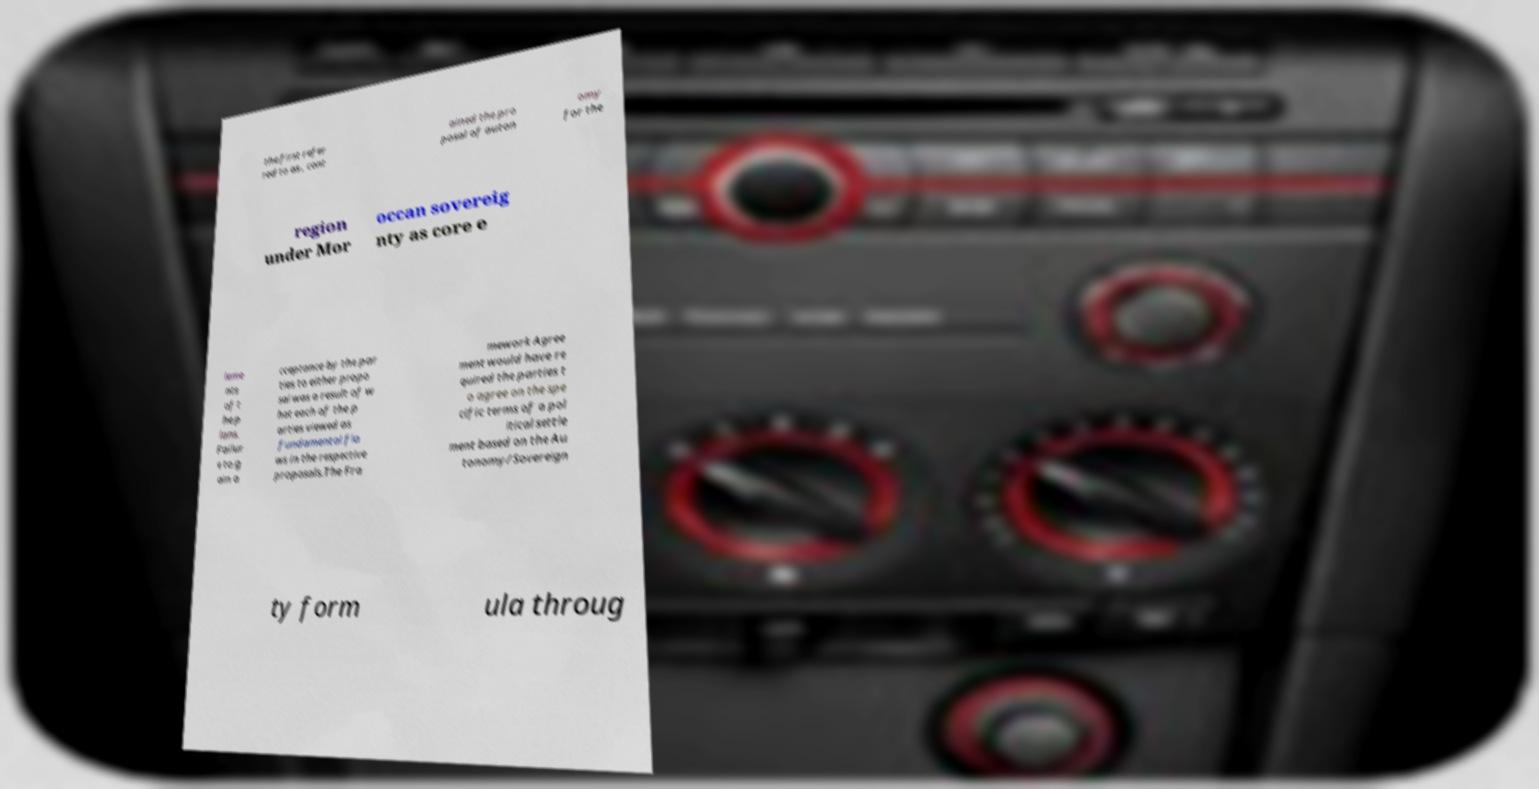Could you extract and type out the text from this image? the first refer red to as , cont ained the pro posal of auton omy for the region under Mor occan sovereig nty as core e leme nts of t he p lans. Failur e to g ain a cceptance by the par ties to either propo sal was a result of w hat each of the p arties viewed as fundamental fla ws in the respective proposals.The Fra mework Agree ment would have re quired the parties t o agree on the spe cific terms of a pol itical settle ment based on the Au tonomy/Sovereign ty form ula throug 